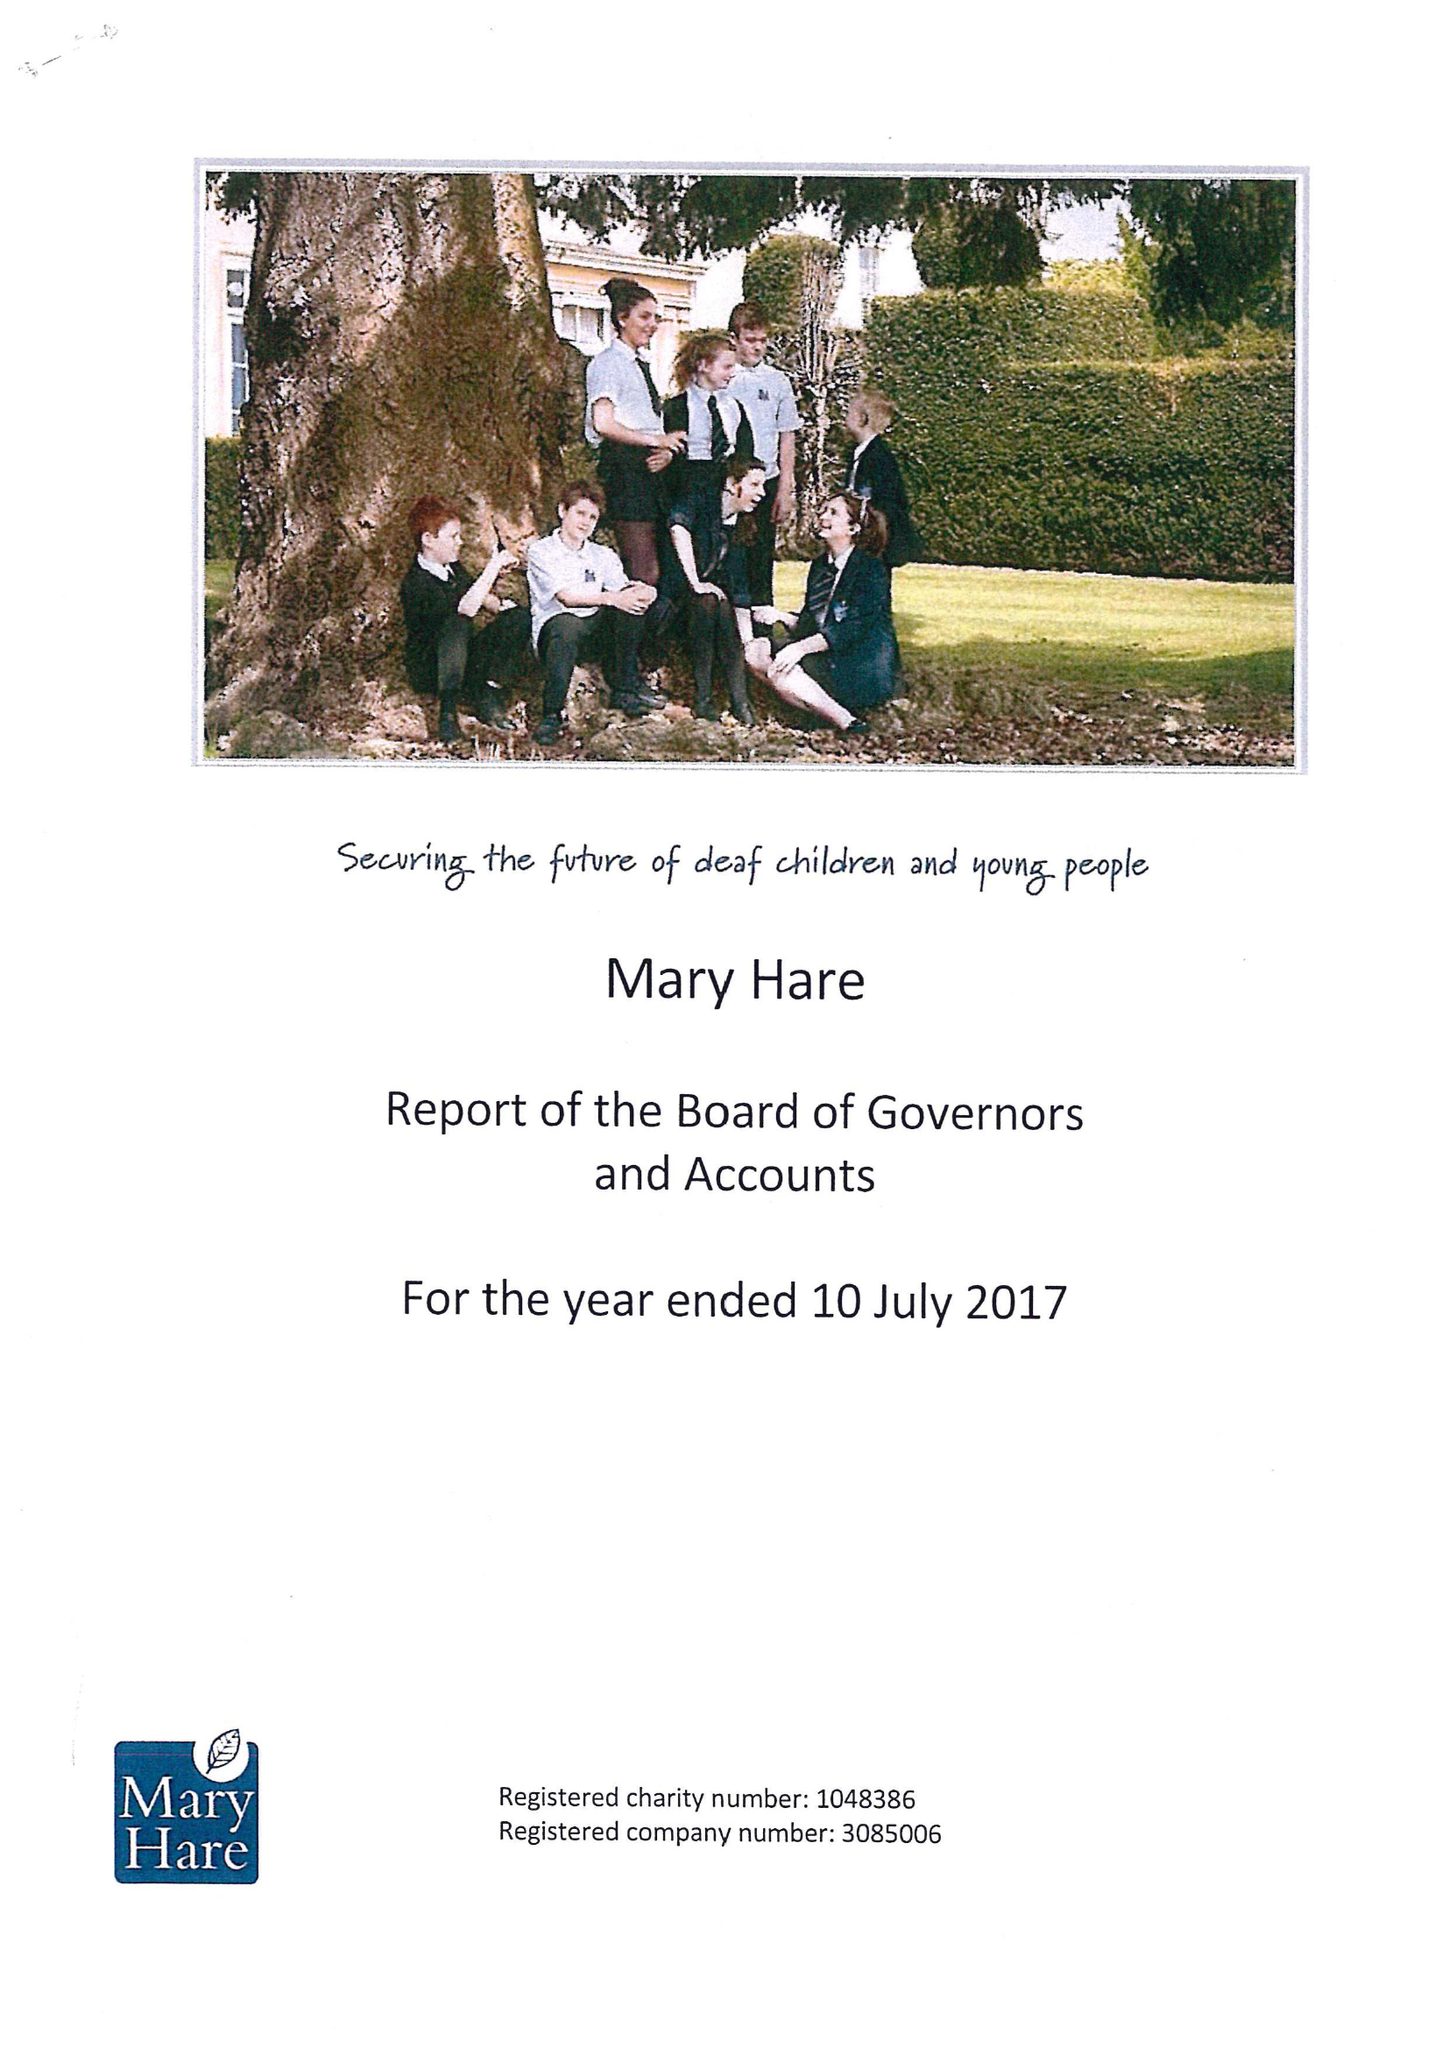What is the value for the address__street_line?
Answer the question using a single word or phrase. NEWBURY 